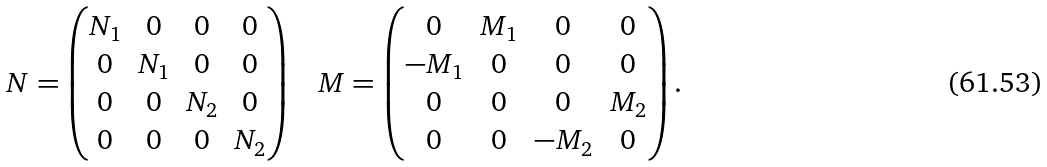<formula> <loc_0><loc_0><loc_500><loc_500>N = \begin{pmatrix} N _ { 1 } & 0 & 0 & 0 \\ 0 & N _ { 1 } & 0 & 0 \\ 0 & 0 & N _ { 2 } & 0 \\ 0 & 0 & 0 & N _ { 2 } \end{pmatrix} \text { \ \ } M = \begin{pmatrix} 0 & M _ { 1 } & 0 & 0 \\ - M _ { 1 } & 0 & 0 & 0 \\ 0 & 0 & 0 & M _ { 2 } \\ 0 & 0 & - M _ { 2 } & 0 \end{pmatrix} .</formula> 